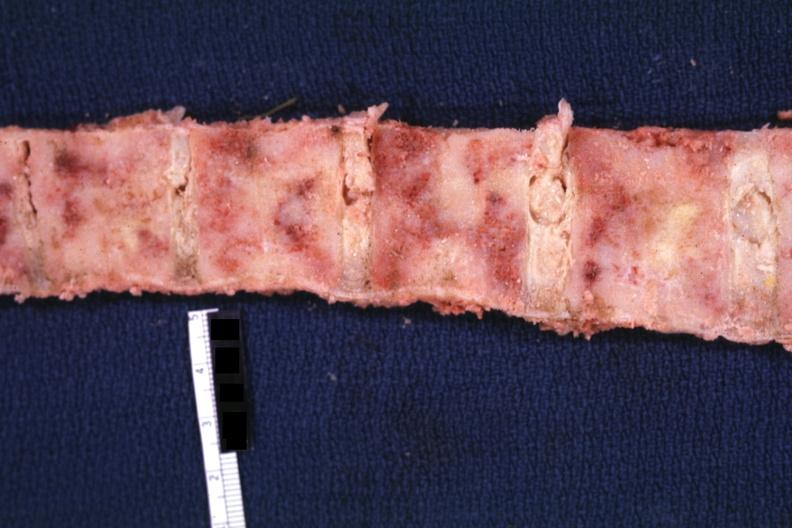s joints present?
Answer the question using a single word or phrase. Yes 